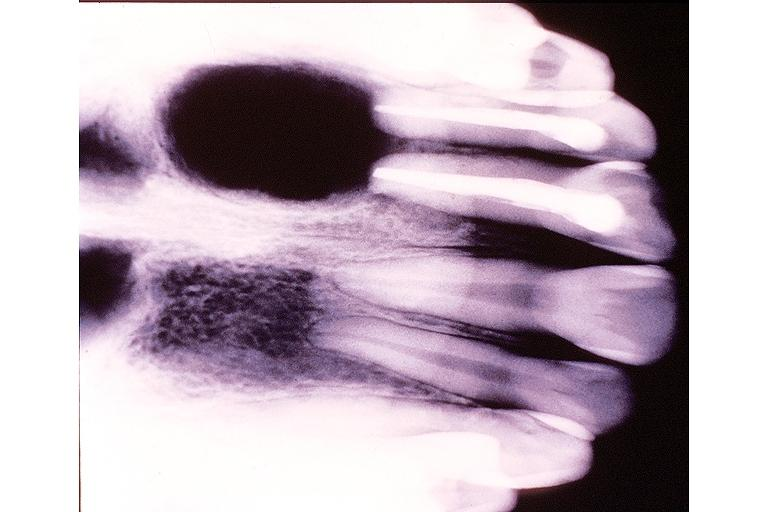does this image show radicular cyst?
Answer the question using a single word or phrase. Yes 